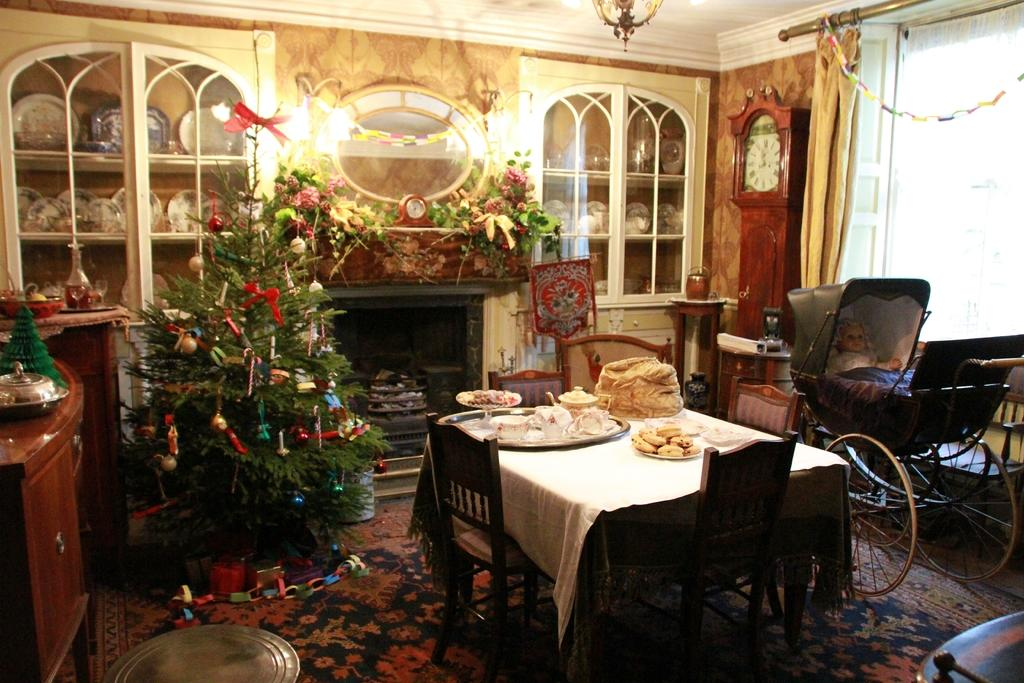What type of tree is in the image? There is a Christmas tree in the image. What is on the table in the image? There is food on a table in the image. What can be used for sitting around the table in the image? There are chairs around the table in the image. How does the page blow in the wind in the image? There is no page or wind present in the image; it features a Christmas tree, food on a table, and chairs around the table. 